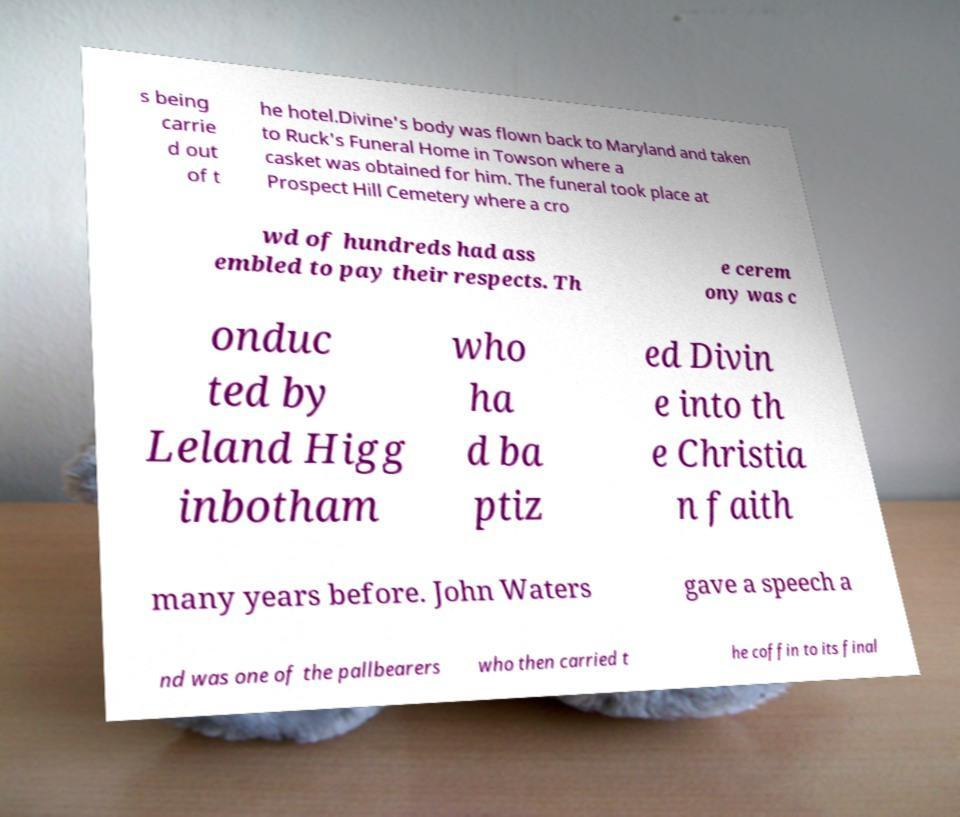Could you extract and type out the text from this image? s being carrie d out of t he hotel.Divine's body was flown back to Maryland and taken to Ruck's Funeral Home in Towson where a casket was obtained for him. The funeral took place at Prospect Hill Cemetery where a cro wd of hundreds had ass embled to pay their respects. Th e cerem ony was c onduc ted by Leland Higg inbotham who ha d ba ptiz ed Divin e into th e Christia n faith many years before. John Waters gave a speech a nd was one of the pallbearers who then carried t he coffin to its final 